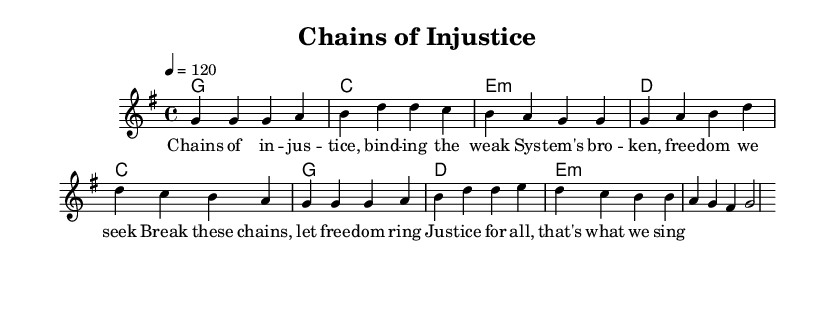What is the key signature of this music? The key signature of the music is G major, which has one sharp (F#). This can be identified by looking at the key signature indication at the beginning of the sheet music.
Answer: G major What is the time signature of this music? The time signature indicated in the sheet music is 4/4, which means there are four beats in a measure, and the quarter note gets one beat. This is shown at the beginning of the score.
Answer: 4/4 What is the tempo marking for the piece? The tempo marking indicates a speed of 120 beats per minute, which is specified at the beginning of the score as "4 = 120". This tells performers how fast to play the music.
Answer: 120 How many measures are in the verse section? The verse consists of four measures as indicated by the melody line, each separated by a bar line. Counting these bars confirms the number of measures.
Answer: Four What chord is used in the first measure of the verse? The first measure of the verse is accompanied by a G major chord as indicated by the chord symbols shown above the melody line.
Answer: G What theme does the chorus address? The chorus addresses the theme of freedom and justice, as shown in the lyrics "Break these chains, let freedom ring / Justice for all, that's what we sing". This reflects the overall critique of the criminal justice system.
Answer: Freedom and Justice What type of lyrical content characterizes this music? The lyrical content critiques the criminal justice system and highlights themes of inequality, as depicted in the lyrics "Chains of injustice, binding the weak / System's broken, freedom we seek". This reflects the socially-conscious nature of the piece.
Answer: Inequality 